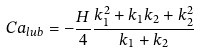Convert formula to latex. <formula><loc_0><loc_0><loc_500><loc_500>C a _ { l u b } = - \frac { H } { 4 } \frac { k _ { 1 } ^ { 2 } + k _ { 1 } k _ { 2 } + k _ { 2 } ^ { 2 } } { k _ { 1 } + k _ { 2 } }</formula> 